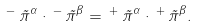Convert formula to latex. <formula><loc_0><loc_0><loc_500><loc_500>\, ^ { - } \, \vec { \pi } ^ { \alpha } \cdot \, ^ { - } \, \vec { \pi } ^ { \beta } = \, ^ { + } \, \vec { \pi } ^ { \alpha } \cdot \, ^ { + } \, \vec { \pi } ^ { \beta } .</formula> 